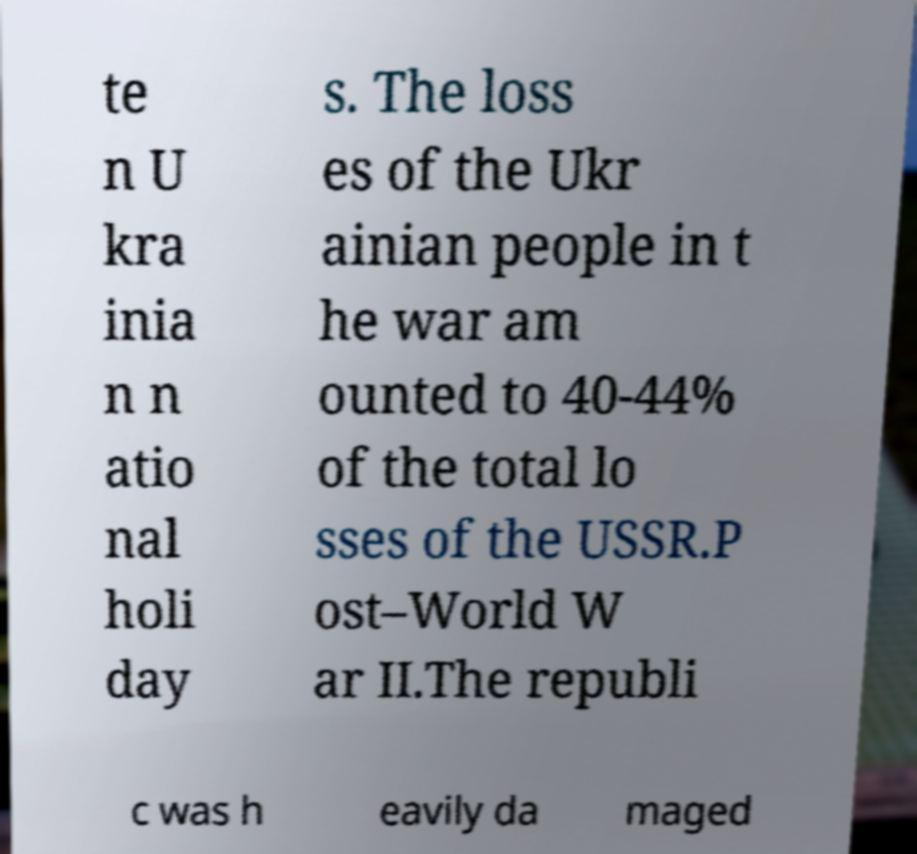I need the written content from this picture converted into text. Can you do that? te n U kra inia n n atio nal holi day s. The loss es of the Ukr ainian people in t he war am ounted to 40-44% of the total lo sses of the USSR.P ost–World W ar II.The republi c was h eavily da maged 